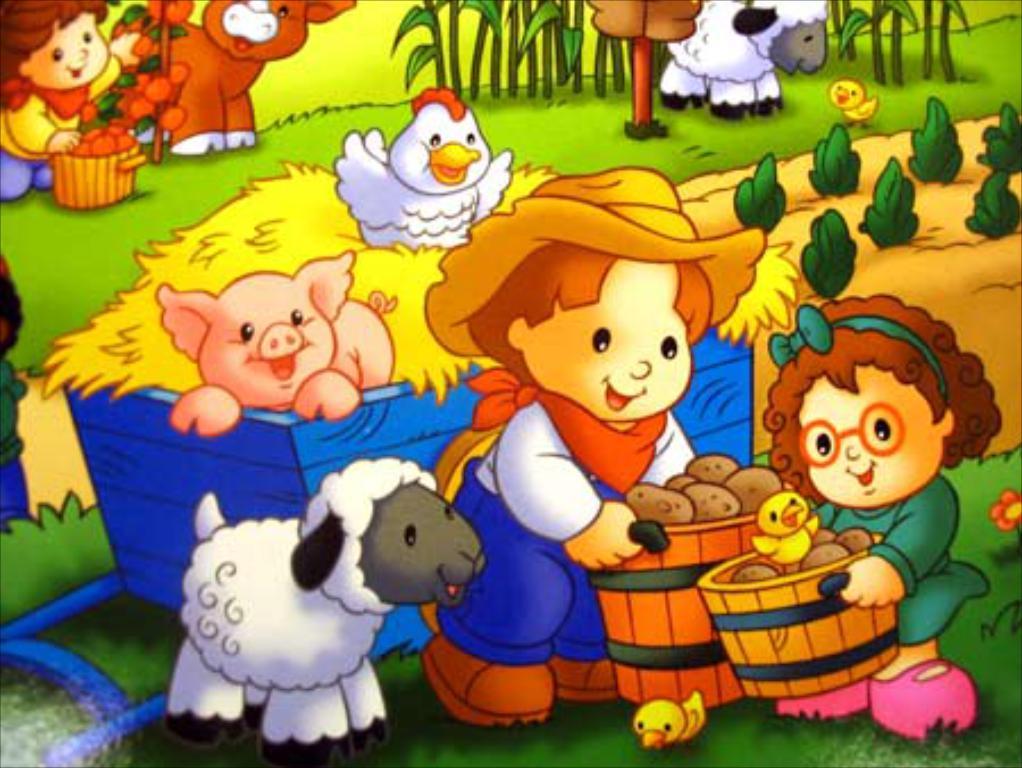Can you describe this image briefly? In this picture we can see few cartoon images. 